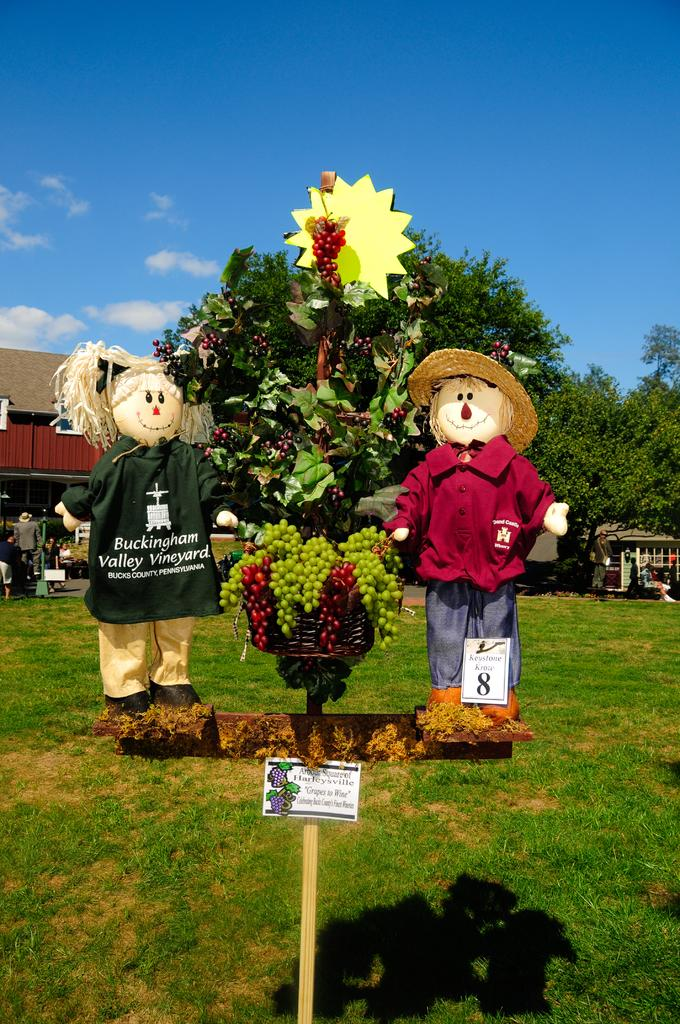What type of fruit can be seen in the image? There are grapes in the image. What else is present in the image besides the grapes? There are toys, grass, buildings, trees, and people in the image. What is the natural environment visible in the image? The natural environment includes grass and trees. What can be seen in the sky in the image? The sky is visible in the background of the image, and clouds are present in the sky. What type of cart can be seen carrying salt in the image? There is no cart or salt present in the image. 